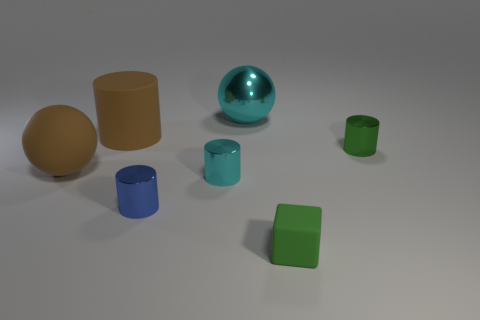Is the number of large matte cylinders that are in front of the tiny cyan shiny thing the same as the number of cylinders behind the blue metallic cylinder?
Your answer should be very brief. No. There is a tiny object right of the small cube that is on the right side of the large ball right of the cyan cylinder; what is its material?
Provide a short and direct response. Metal. There is a cylinder that is both on the right side of the large brown cylinder and behind the cyan shiny cylinder; what is its size?
Your answer should be very brief. Small. Is the shape of the small matte object the same as the large cyan metal thing?
Your response must be concise. No. The small green object that is the same material as the brown cylinder is what shape?
Ensure brevity in your answer.  Cube. What number of big things are red matte blocks or blue objects?
Provide a succinct answer. 0. Is there a matte sphere left of the green thing that is behind the blue metallic object?
Provide a succinct answer. Yes. Is there a small purple thing?
Offer a terse response. No. What color is the ball in front of the cylinder that is to the right of the block?
Your answer should be very brief. Brown. What is the material of the big brown object that is the same shape as the big cyan object?
Your answer should be very brief. Rubber. 